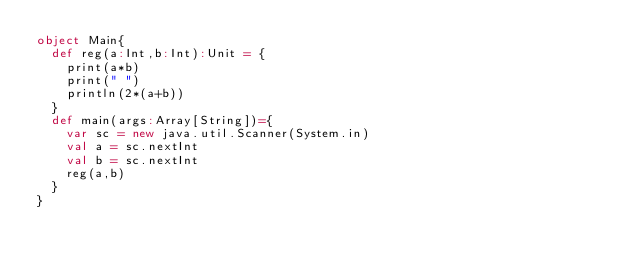Convert code to text. <code><loc_0><loc_0><loc_500><loc_500><_Scala_>object Main{
  def reg(a:Int,b:Int):Unit = {
    print(a*b)
    print(" ")
    println(2*(a+b))
  }
  def main(args:Array[String])={
    var sc = new java.util.Scanner(System.in)
    val a = sc.nextInt
    val b = sc.nextInt
    reg(a,b)
  }
}</code> 